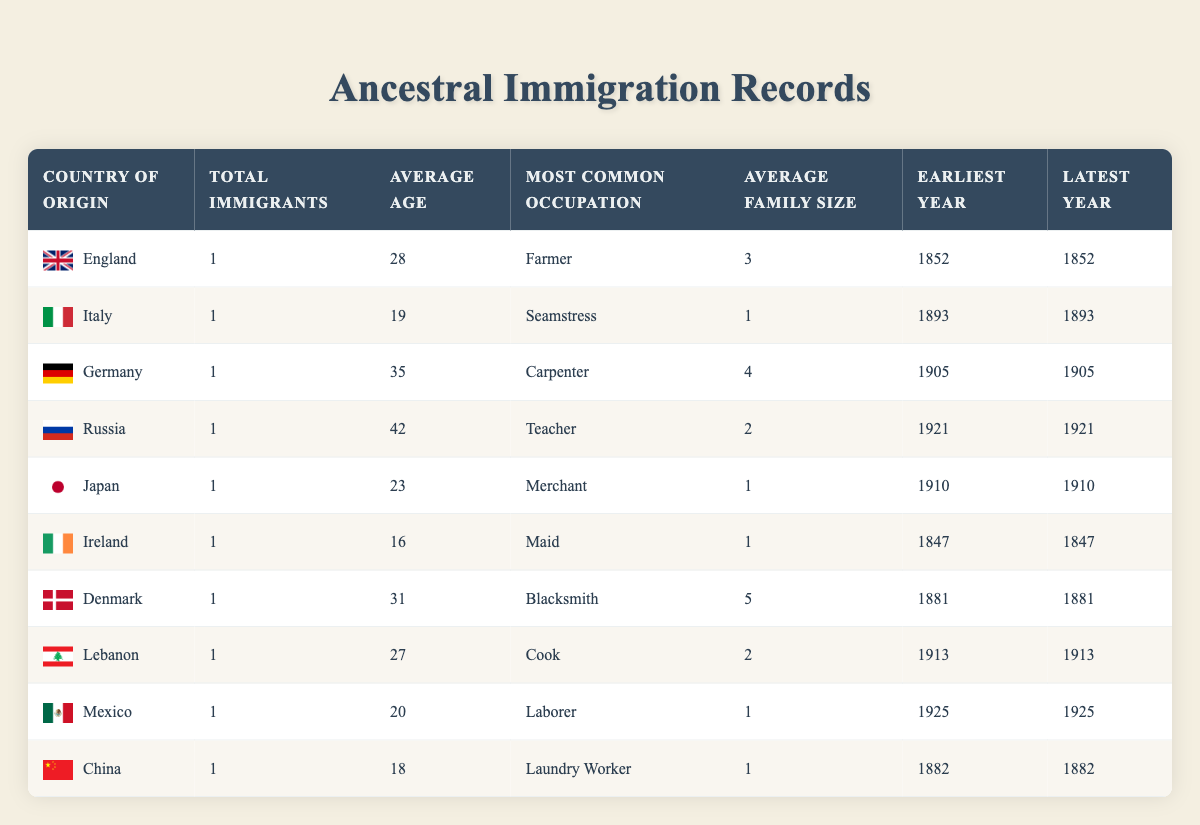What was the most common occupation among the immigrants? To find the most common occupation, I will look at the 'Most Common Occupation' column in the table. The occupations listed are Farmer, Seamstress, Carpenter, Teacher, Merchant, Maid, Blacksmith, Cook, Laborer, and Laundry Worker. Among these, every country listed has a different occupation for its immigrant record, indicating there is no repetition. Thus, there is no single common occupation among all listed immigrants.
Answer: None From which country did the oldest immigrant originate? The 'Average Age' column indicates the age of each immigrant at the time of immigration. The oldest age listed is 42 for Olga Petrov from Russia, so I check the 'Country of Origin' column for her entry to confirm that she immigrated from Russia.
Answer: Russia How many total immigrants came from the European countries listed? I will sum the total immigrants from each European country in the table: England (1), Italy (1), Germany (1), Ireland (1), Denmark (1). Adding these gives a total of 5 immigrants from Europe.
Answer: 5 What is the average family size of immigrants from Asian countries in this table? The Asian countries listed are Japan and China. Looking at the 'Average Family Size' column, Yuki Tanaka from Japan has a family size of 1, and Mei Chen from China has a family size of 1. Adding these gives a total family size of 1 + 1 = 2. There are 2 data points (1 for each country), so dividing gives an average of 2/2 = 1.
Answer: 1 Was there any female immigrant who arrived before 1900? To answer this, I check the 'Year of Immigration' and 'Occupation' for each individual to identify female immigrants. Both Maria Rossi (1893) and Aoife O'Sullivan (1847) are females. Aoife O'Sullivan arrived in 1847, which is before 1900.
Answer: Yes How many years passed between the earliest and latest immigration recorded? The table indicates the earliest year of immigration is 1847 (Ireland) and the latest year is 1925 (Mexico). To find the difference in years, I subtract 1847 from 1925, giving 1925 - 1847 = 78 years.
Answer: 78 Which immigrant had the largest family size? I will look through the 'Average Family Size' column to identify the largest family size listed. The largest is 5, associated with Lars Andersen from Denmark.
Answer: 5 Are there more immigrants from Asian countries compared to those from Europe? The total number of immigrants from Asian countries in this table is 2 (Japan and China). The total number from European countries is 5 (England, Italy, Germany, Ireland, Denmark). Since 2 is less than 5, it confirms that there are fewer immigrants from Asia compared to Europe.
Answer: No 